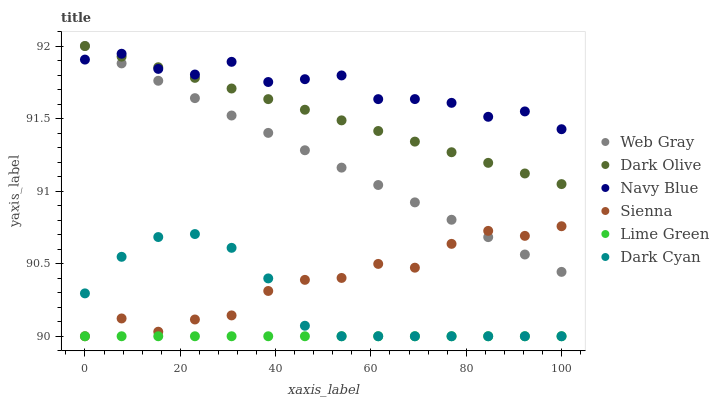Does Lime Green have the minimum area under the curve?
Answer yes or no. Yes. Does Navy Blue have the maximum area under the curve?
Answer yes or no. Yes. Does Dark Olive have the minimum area under the curve?
Answer yes or no. No. Does Dark Olive have the maximum area under the curve?
Answer yes or no. No. Is Lime Green the smoothest?
Answer yes or no. Yes. Is Navy Blue the roughest?
Answer yes or no. Yes. Is Dark Olive the smoothest?
Answer yes or no. No. Is Dark Olive the roughest?
Answer yes or no. No. Does Sienna have the lowest value?
Answer yes or no. Yes. Does Dark Olive have the lowest value?
Answer yes or no. No. Does Dark Olive have the highest value?
Answer yes or no. Yes. Does Navy Blue have the highest value?
Answer yes or no. No. Is Lime Green less than Navy Blue?
Answer yes or no. Yes. Is Navy Blue greater than Dark Cyan?
Answer yes or no. Yes. Does Sienna intersect Dark Cyan?
Answer yes or no. Yes. Is Sienna less than Dark Cyan?
Answer yes or no. No. Is Sienna greater than Dark Cyan?
Answer yes or no. No. Does Lime Green intersect Navy Blue?
Answer yes or no. No. 